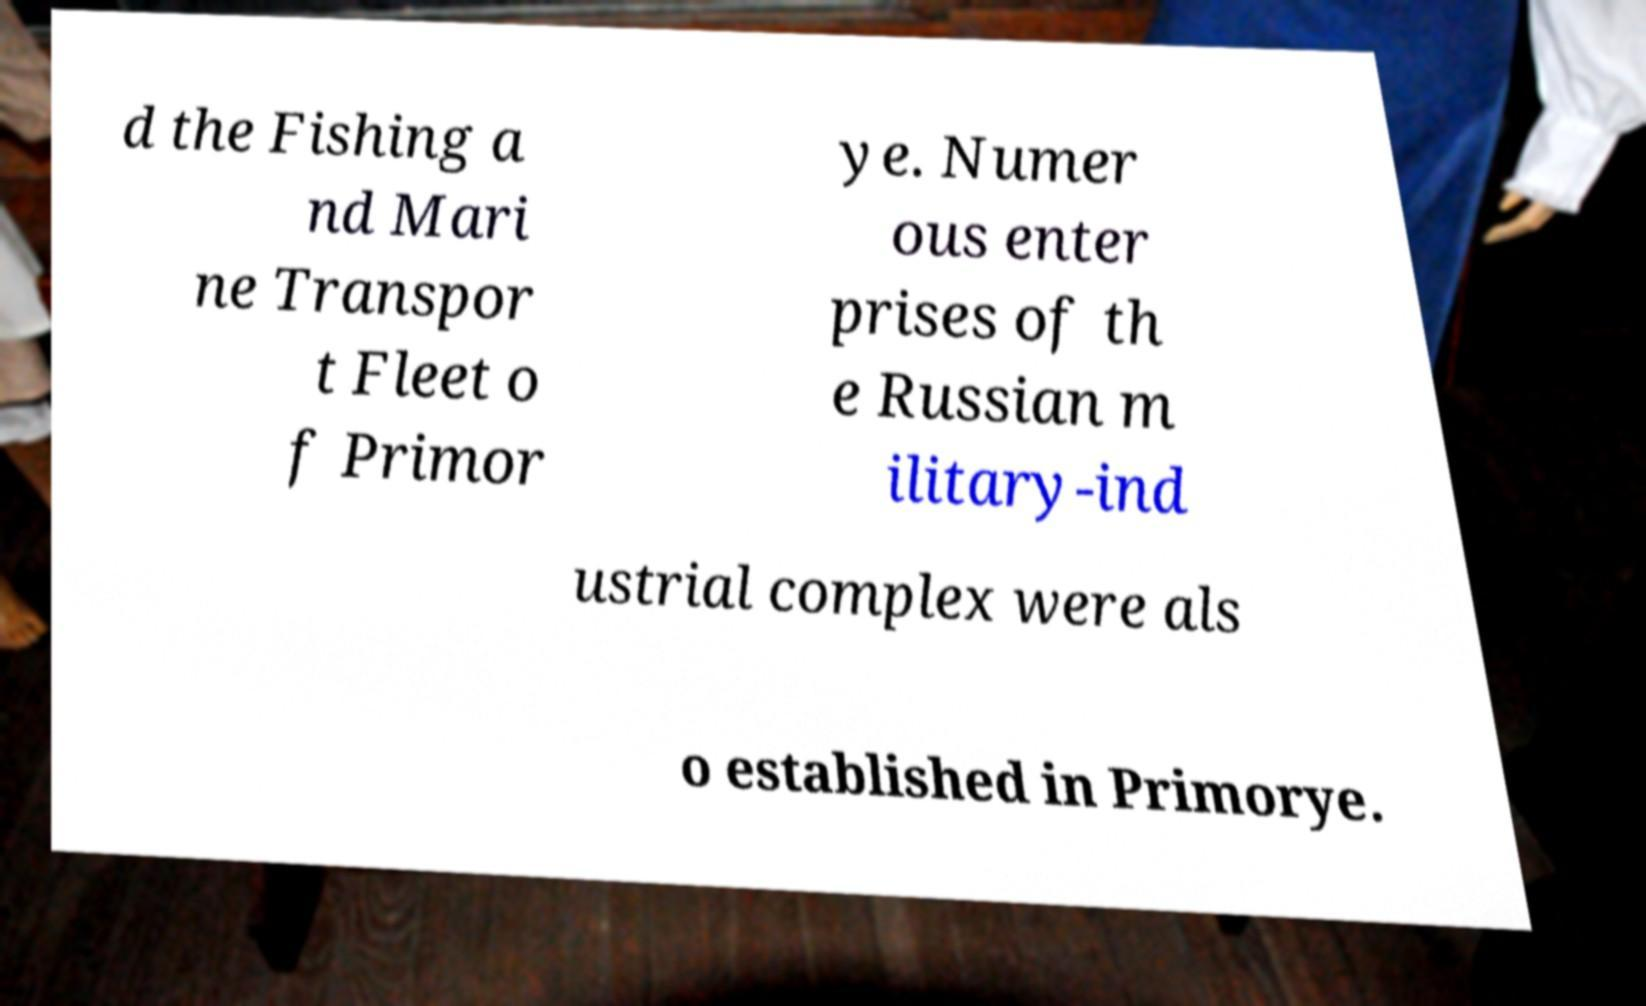Please identify and transcribe the text found in this image. d the Fishing a nd Mari ne Transpor t Fleet o f Primor ye. Numer ous enter prises of th e Russian m ilitary-ind ustrial complex were als o established in Primorye. 